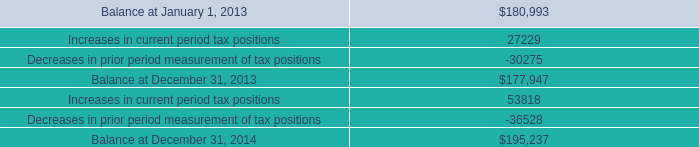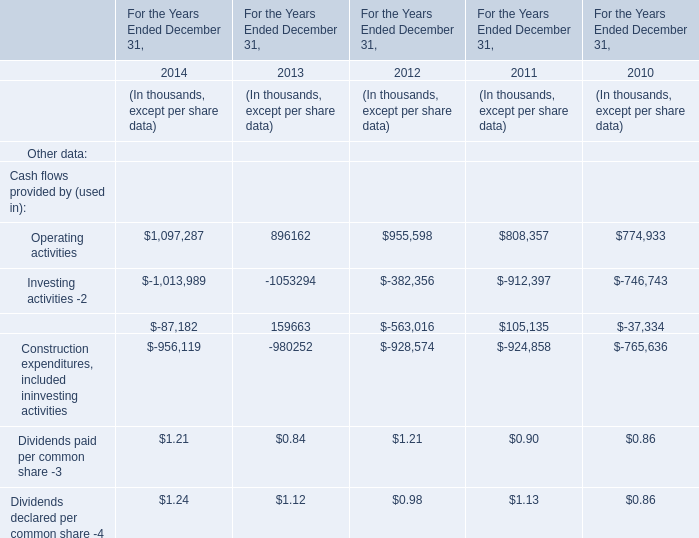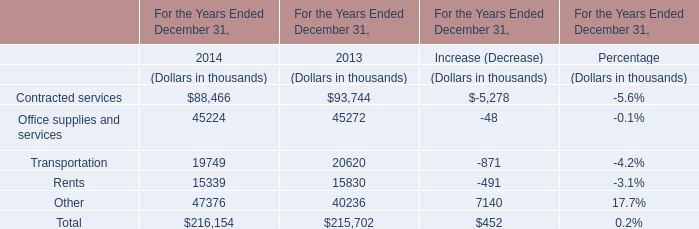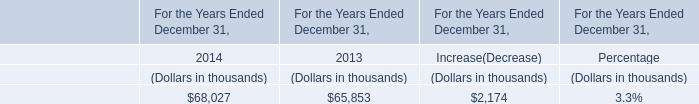What's the sum of the Investing activities -2 in the years where Financing activities -2 is positive? (in thousand) 
Computations: (-1053294 - 912397)
Answer: -1965691.0. 